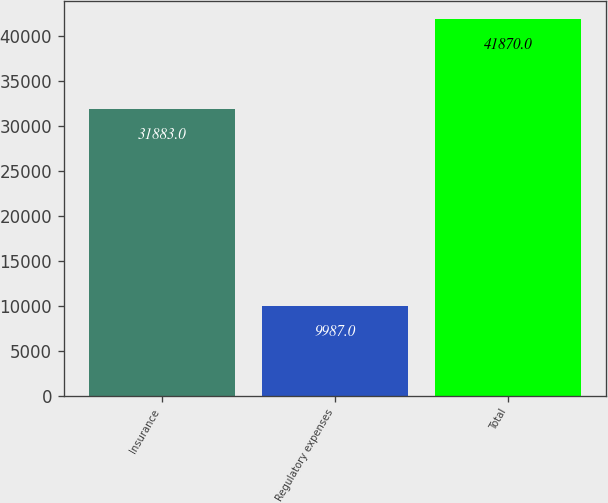Convert chart to OTSL. <chart><loc_0><loc_0><loc_500><loc_500><bar_chart><fcel>Insurance<fcel>Regulatory expenses<fcel>Total<nl><fcel>31883<fcel>9987<fcel>41870<nl></chart> 